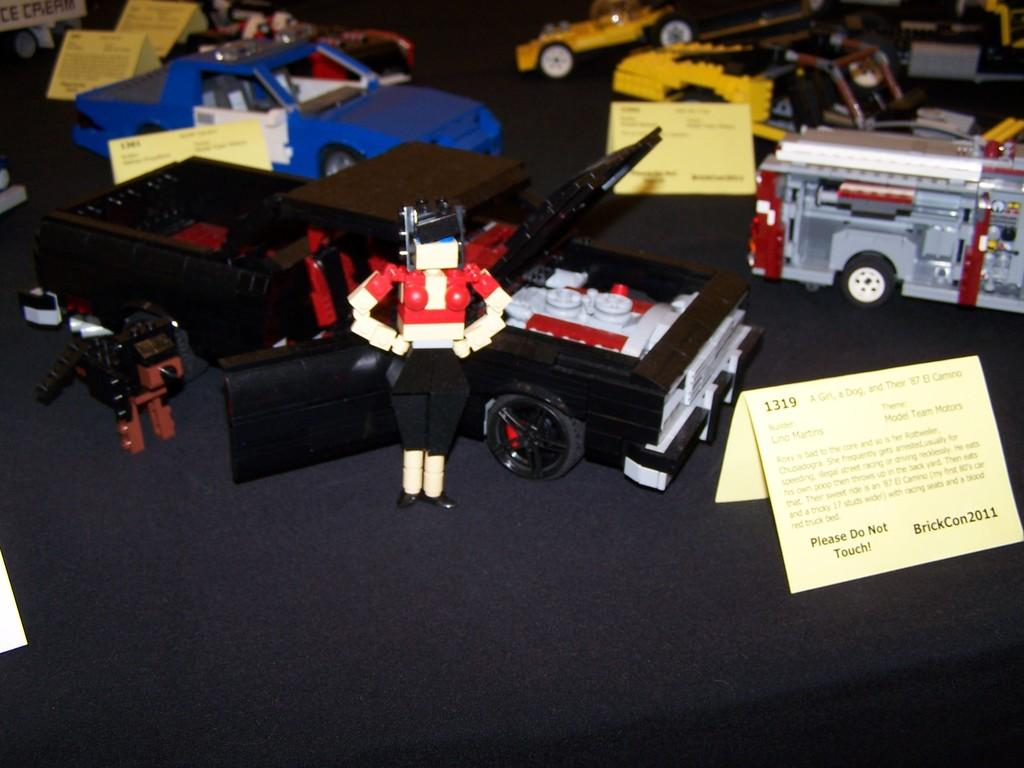<image>
Create a compact narrative representing the image presented. a little sign for BrickCon2011 on the ground 